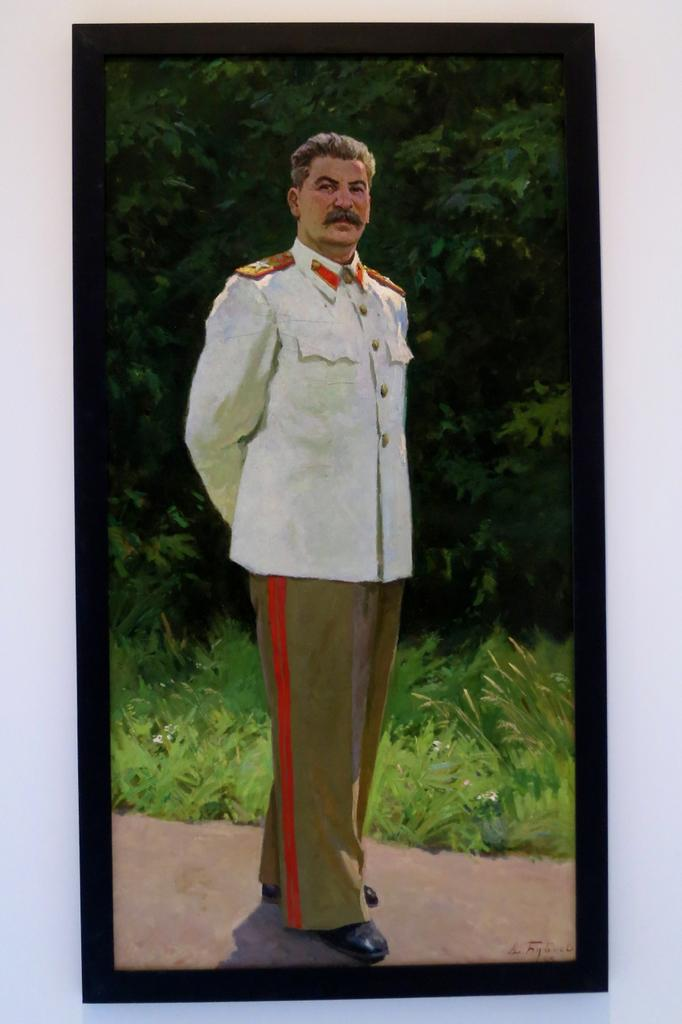What is the main subject of the image? There is a man standing in the middle of the image. What is the man wearing? The man is wearing a shirt, trousers, and black shoes. What can be seen behind the man? There are green trees behind the man. What type of crow is sitting on the man's shoulder in the image? There is no crow present in the image; the man is standing alone. What is the man doing with his mouth in the image? There is no indication of the man's mouth or any activity involving his mouth in the image. 